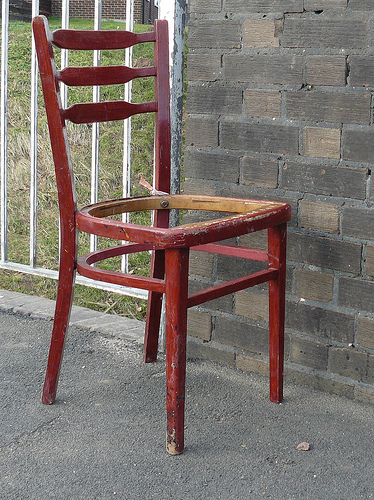<image>
Is there a chair on the grass? No. The chair is not positioned on the grass. They may be near each other, but the chair is not supported by or resting on top of the grass. Where is the chair in relation to the wall? Is it in front of the wall? Yes. The chair is positioned in front of the wall, appearing closer to the camera viewpoint. 